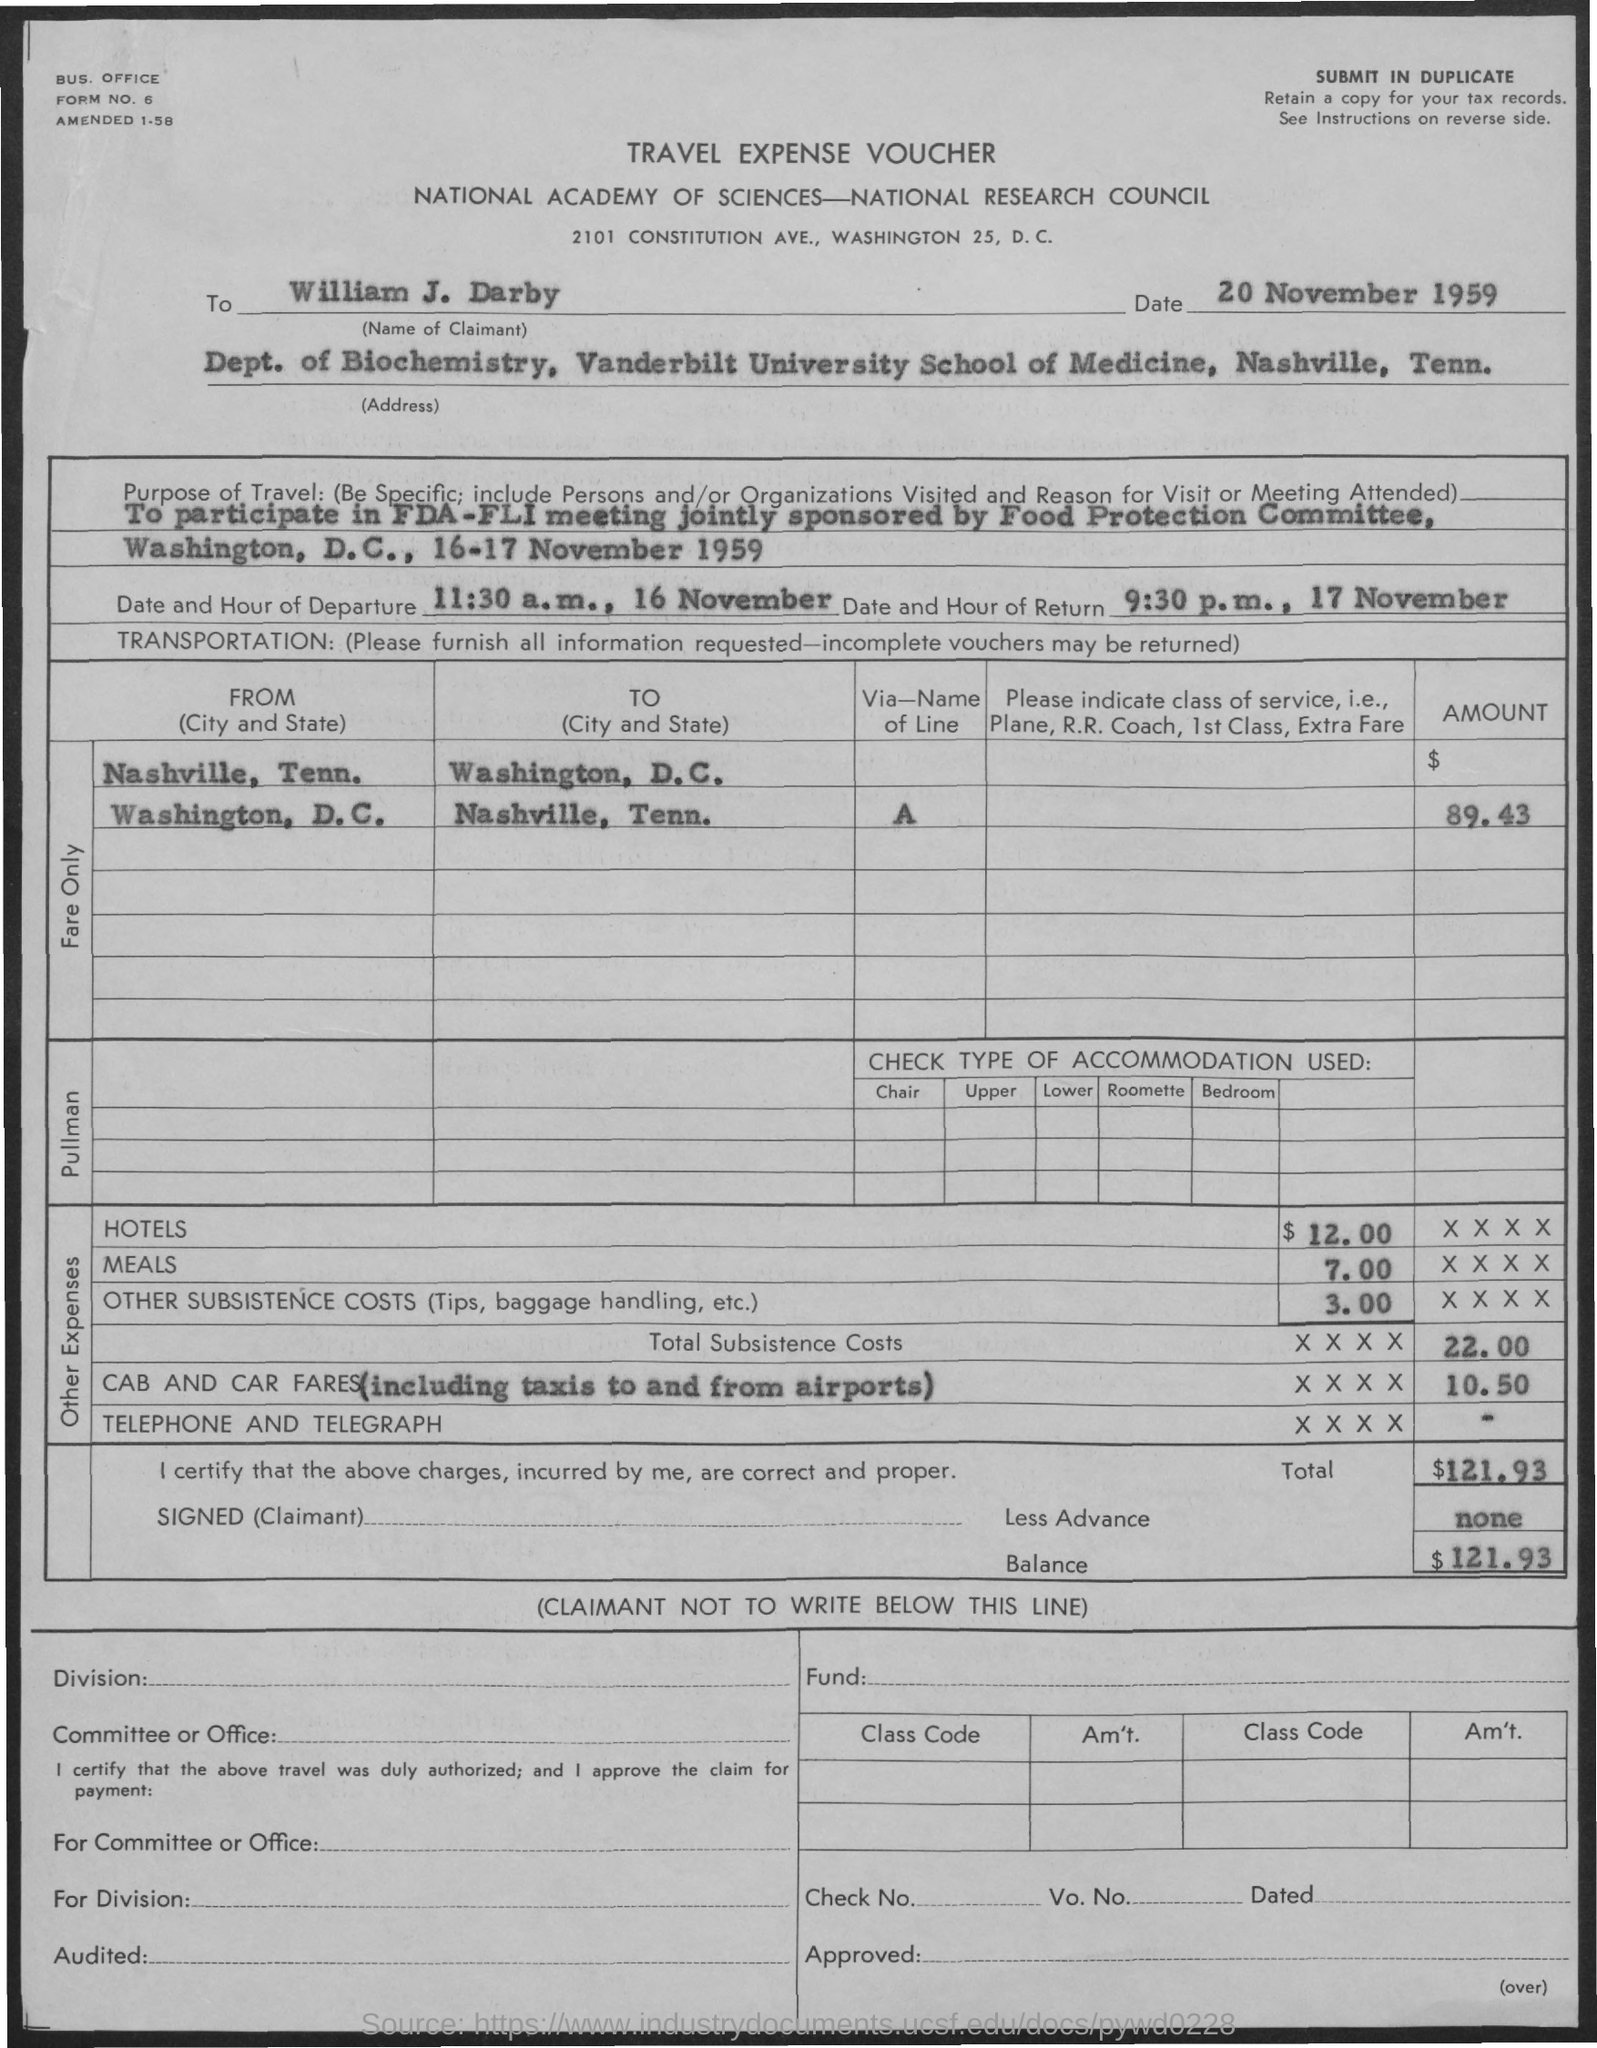What type of voucher is given here?
Your answer should be compact. TRAVEL EXPENSE VOUCHER. What is the name of the person given in the voucher?
Give a very brief answer. William J. Darby. What is the date and hour of departure as mentioned in the voucher?
Make the answer very short. 11:30 a.m., 16 November. What is the date and hour of return as mentioned in the voucher?
Make the answer very short. 9:30 p.m., 17 November. What is the balance amount given in the voucher?
Make the answer very short. $121.93. 